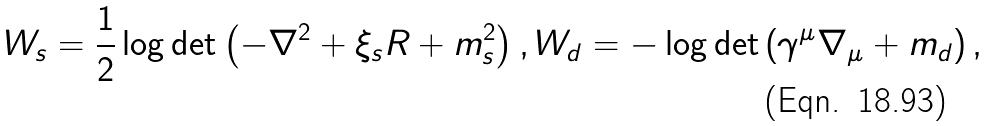<formula> <loc_0><loc_0><loc_500><loc_500>W _ { s } = \frac { 1 } { 2 } \log \det \left ( - \nabla ^ { 2 } + \xi _ { s } R + m _ { s } ^ { 2 } \right ) , W _ { d } = - \log \det \left ( \gamma ^ { \mu } \nabla _ { \mu } + m _ { d } \right ) ,</formula> 